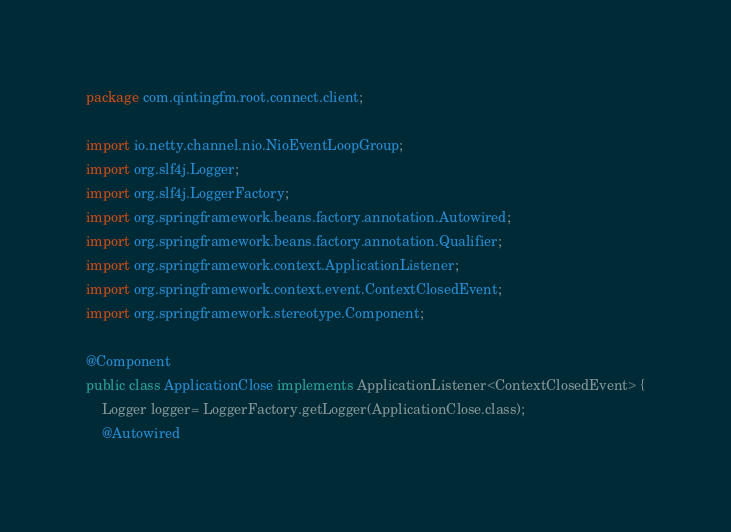<code> <loc_0><loc_0><loc_500><loc_500><_Java_>package com.qintingfm.root.connect.client;

import io.netty.channel.nio.NioEventLoopGroup;
import org.slf4j.Logger;
import org.slf4j.LoggerFactory;
import org.springframework.beans.factory.annotation.Autowired;
import org.springframework.beans.factory.annotation.Qualifier;
import org.springframework.context.ApplicationListener;
import org.springframework.context.event.ContextClosedEvent;
import org.springframework.stereotype.Component;

@Component
public class ApplicationClose implements ApplicationListener<ContextClosedEvent> {
    Logger logger= LoggerFactory.getLogger(ApplicationClose.class);
    @Autowired</code> 